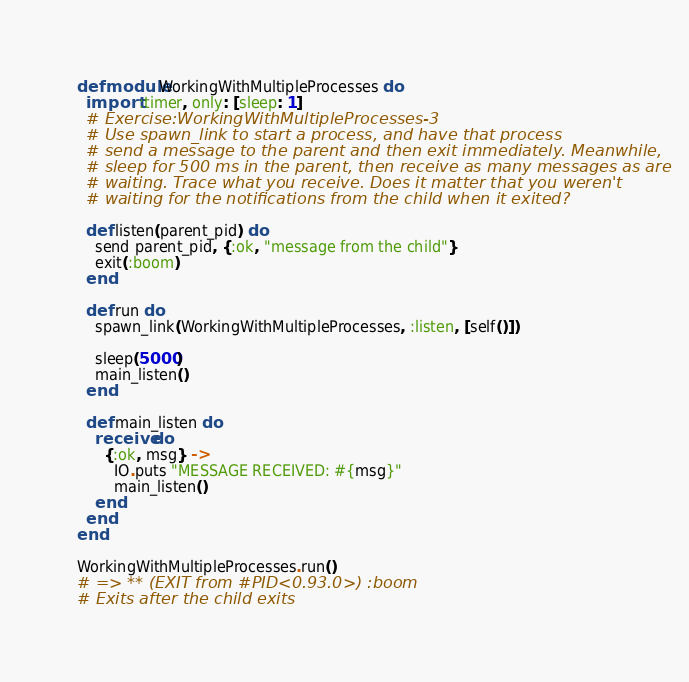Convert code to text. <code><loc_0><loc_0><loc_500><loc_500><_Elixir_>defmodule WorkingWithMultipleProcesses do
  import :timer, only: [sleep: 1]
  # Exercise:WorkingWithMultipleProcesses-3
  # Use spawn_link to start a process, and have that process
  # send a message to the parent and then exit immediately. Meanwhile,
  # sleep for 500 ms in the parent, then receive as many messages as are
  # waiting. Trace what you receive. Does it matter that you weren't
  # waiting for the notifications from the child when it exited?

  def listen(parent_pid) do
    send parent_pid, {:ok, "message from the child"}
    exit(:boom)
  end

  def run do
    spawn_link(WorkingWithMultipleProcesses, :listen, [self()])

    sleep(5000)
    main_listen()
  end

  def main_listen do
    receive do
      {:ok, msg} ->
        IO.puts "MESSAGE RECEIVED: #{msg}"
        main_listen()
    end
  end
end

WorkingWithMultipleProcesses.run()
# => ** (EXIT from #PID<0.93.0>) :boom
# Exits after the child exits

</code> 